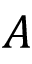<formula> <loc_0><loc_0><loc_500><loc_500>A</formula> 